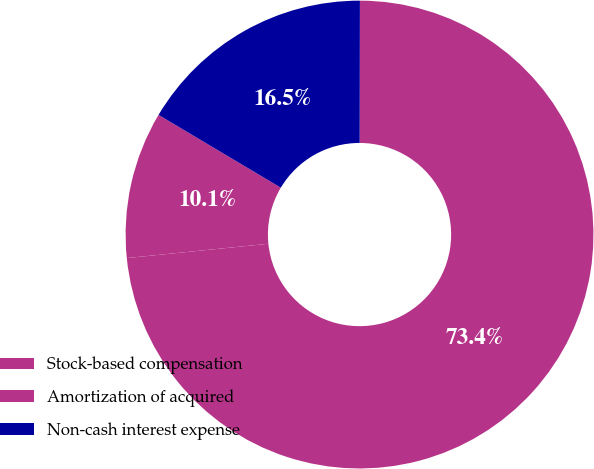<chart> <loc_0><loc_0><loc_500><loc_500><pie_chart><fcel>Stock-based compensation<fcel>Amortization of acquired<fcel>Non-cash interest expense<nl><fcel>73.37%<fcel>10.15%<fcel>16.48%<nl></chart> 